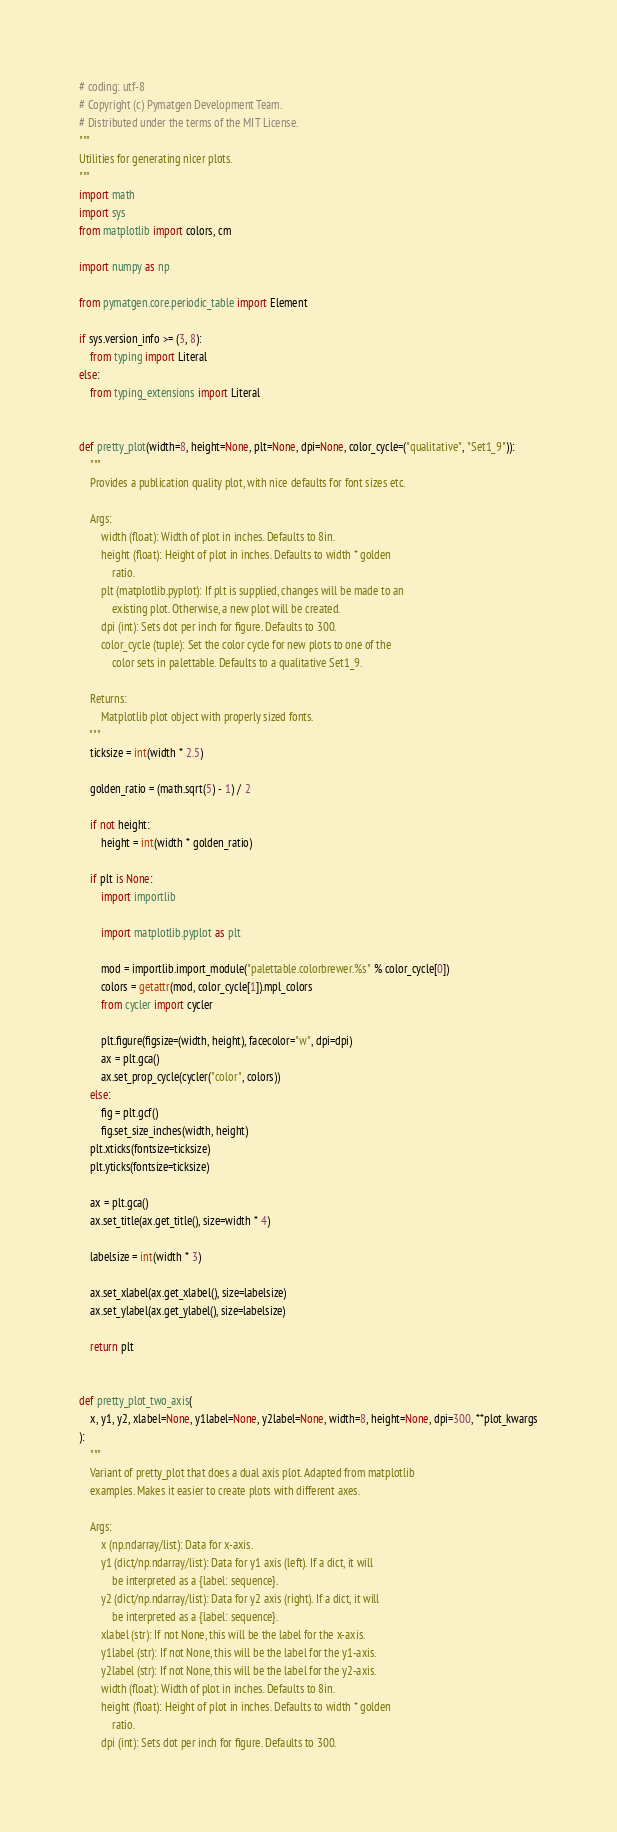<code> <loc_0><loc_0><loc_500><loc_500><_Python_># coding: utf-8
# Copyright (c) Pymatgen Development Team.
# Distributed under the terms of the MIT License.
"""
Utilities for generating nicer plots.
"""
import math
import sys
from matplotlib import colors, cm

import numpy as np

from pymatgen.core.periodic_table import Element

if sys.version_info >= (3, 8):
    from typing import Literal
else:
    from typing_extensions import Literal


def pretty_plot(width=8, height=None, plt=None, dpi=None, color_cycle=("qualitative", "Set1_9")):
    """
    Provides a publication quality plot, with nice defaults for font sizes etc.

    Args:
        width (float): Width of plot in inches. Defaults to 8in.
        height (float): Height of plot in inches. Defaults to width * golden
            ratio.
        plt (matplotlib.pyplot): If plt is supplied, changes will be made to an
            existing plot. Otherwise, a new plot will be created.
        dpi (int): Sets dot per inch for figure. Defaults to 300.
        color_cycle (tuple): Set the color cycle for new plots to one of the
            color sets in palettable. Defaults to a qualitative Set1_9.

    Returns:
        Matplotlib plot object with properly sized fonts.
    """
    ticksize = int(width * 2.5)

    golden_ratio = (math.sqrt(5) - 1) / 2

    if not height:
        height = int(width * golden_ratio)

    if plt is None:
        import importlib

        import matplotlib.pyplot as plt

        mod = importlib.import_module("palettable.colorbrewer.%s" % color_cycle[0])
        colors = getattr(mod, color_cycle[1]).mpl_colors
        from cycler import cycler

        plt.figure(figsize=(width, height), facecolor="w", dpi=dpi)
        ax = plt.gca()
        ax.set_prop_cycle(cycler("color", colors))
    else:
        fig = plt.gcf()
        fig.set_size_inches(width, height)
    plt.xticks(fontsize=ticksize)
    plt.yticks(fontsize=ticksize)

    ax = plt.gca()
    ax.set_title(ax.get_title(), size=width * 4)

    labelsize = int(width * 3)

    ax.set_xlabel(ax.get_xlabel(), size=labelsize)
    ax.set_ylabel(ax.get_ylabel(), size=labelsize)

    return plt


def pretty_plot_two_axis(
    x, y1, y2, xlabel=None, y1label=None, y2label=None, width=8, height=None, dpi=300, **plot_kwargs
):
    """
    Variant of pretty_plot that does a dual axis plot. Adapted from matplotlib
    examples. Makes it easier to create plots with different axes.

    Args:
        x (np.ndarray/list): Data for x-axis.
        y1 (dict/np.ndarray/list): Data for y1 axis (left). If a dict, it will
            be interpreted as a {label: sequence}.
        y2 (dict/np.ndarray/list): Data for y2 axis (right). If a dict, it will
            be interpreted as a {label: sequence}.
        xlabel (str): If not None, this will be the label for the x-axis.
        y1label (str): If not None, this will be the label for the y1-axis.
        y2label (str): If not None, this will be the label for the y2-axis.
        width (float): Width of plot in inches. Defaults to 8in.
        height (float): Height of plot in inches. Defaults to width * golden
            ratio.
        dpi (int): Sets dot per inch for figure. Defaults to 300.</code> 